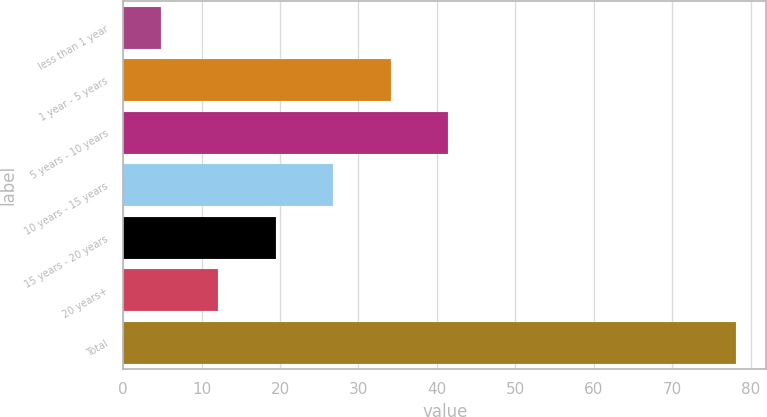<chart> <loc_0><loc_0><loc_500><loc_500><bar_chart><fcel>less than 1 year<fcel>1 year - 5 years<fcel>5 years - 10 years<fcel>10 years - 15 years<fcel>15 years - 20 years<fcel>20 years+<fcel>Total<nl><fcel>4.8<fcel>34.12<fcel>41.45<fcel>26.79<fcel>19.46<fcel>12.13<fcel>78.1<nl></chart> 